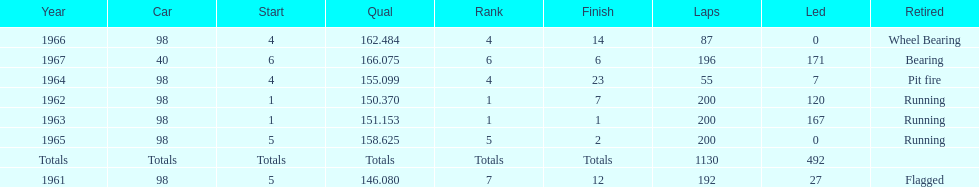What car achieved the highest qual? 40. 